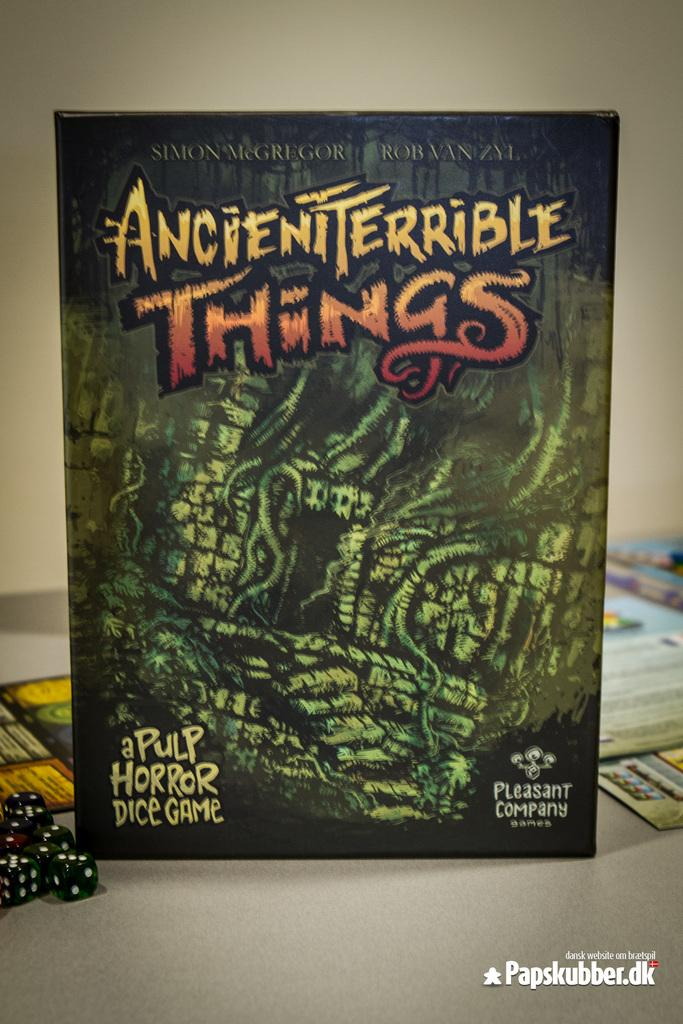<image>
Create a compact narrative representing the image presented. Horror dice game titled "Ancient Terrible Things" on top of a table. 